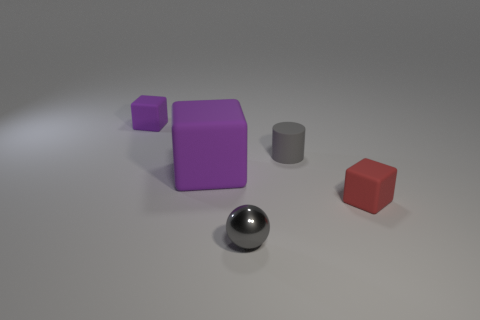Add 4 tiny gray rubber objects. How many objects exist? 9 Subtract all blocks. How many objects are left? 2 Subtract all brown rubber objects. Subtract all small gray matte objects. How many objects are left? 4 Add 2 gray balls. How many gray balls are left? 3 Add 3 big purple matte things. How many big purple matte things exist? 4 Subtract 0 brown balls. How many objects are left? 5 